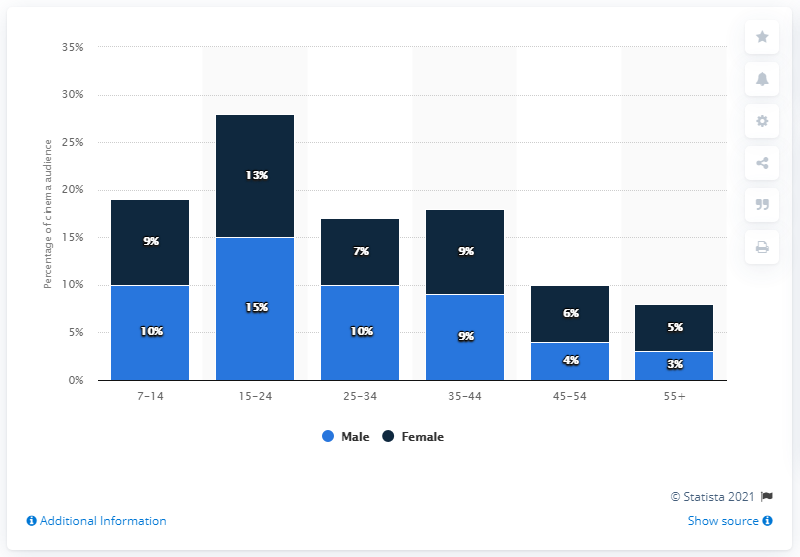Outline some significant characteristics in this image. The tallest combined bar can be found in the 15-24 age group. In the age group of 35-44, both males and females have approximately equal representation. 